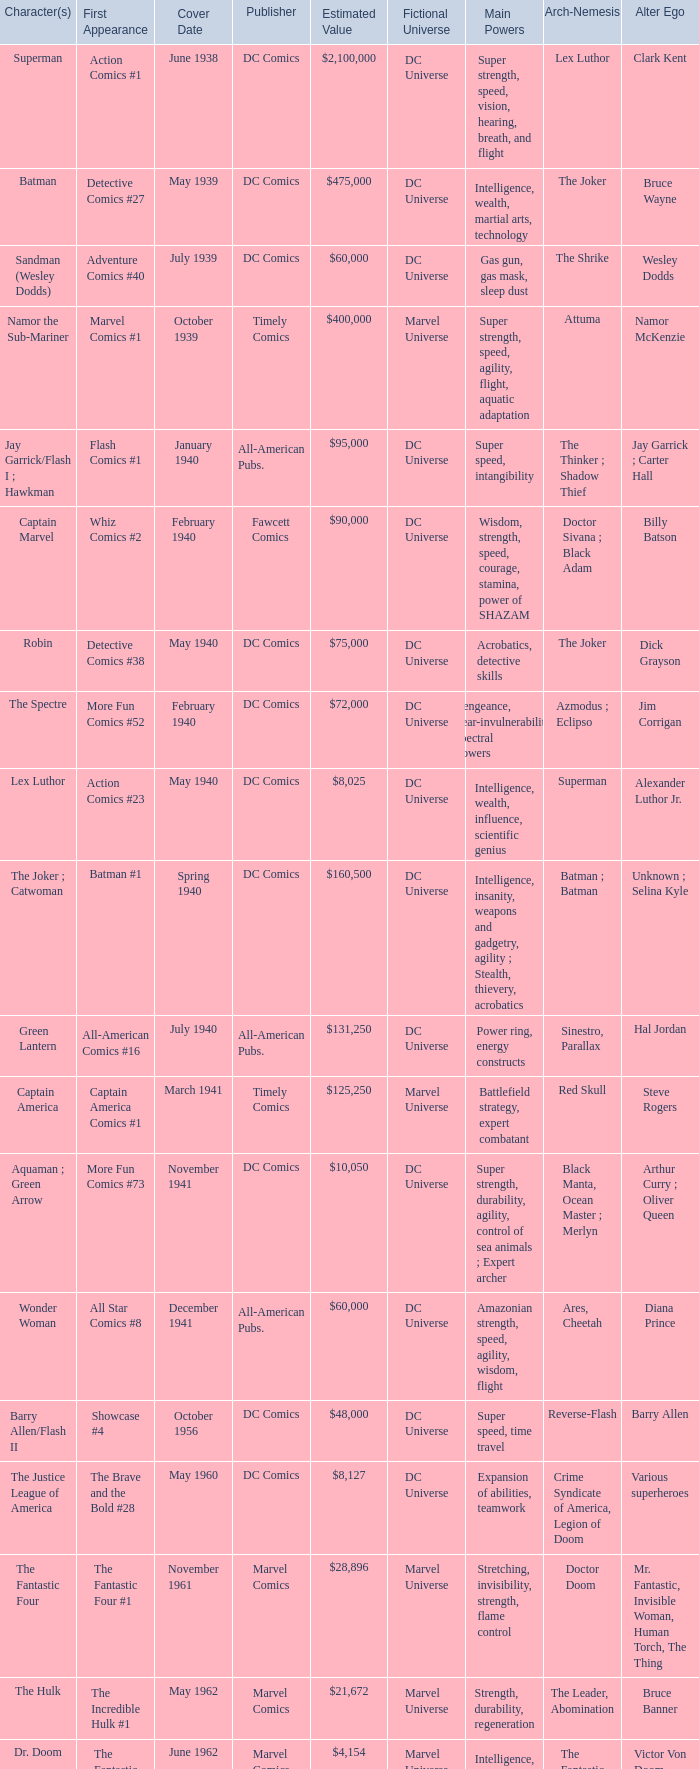Who publishes Wolverine? Marvel Comics. 